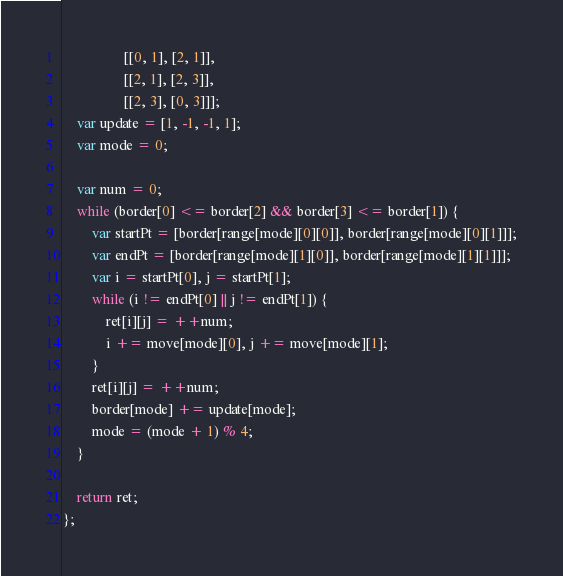Convert code to text. <code><loc_0><loc_0><loc_500><loc_500><_JavaScript_>                 [[0, 1], [2, 1]],
                 [[2, 1], [2, 3]],
                 [[2, 3], [0, 3]]];
    var update = [1, -1, -1, 1];
    var mode = 0;
    
    var num = 0;
    while (border[0] <= border[2] && border[3] <= border[1]) {
        var startPt = [border[range[mode][0][0]], border[range[mode][0][1]]];
        var endPt = [border[range[mode][1][0]], border[range[mode][1][1]]];
        var i = startPt[0], j = startPt[1];
        while (i != endPt[0] || j != endPt[1]) {
            ret[i][j] = ++num;
            i += move[mode][0], j += move[mode][1];
        }
        ret[i][j] = ++num;
        border[mode] += update[mode];
        mode = (mode + 1) % 4;
    }
    
    return ret;
};</code> 